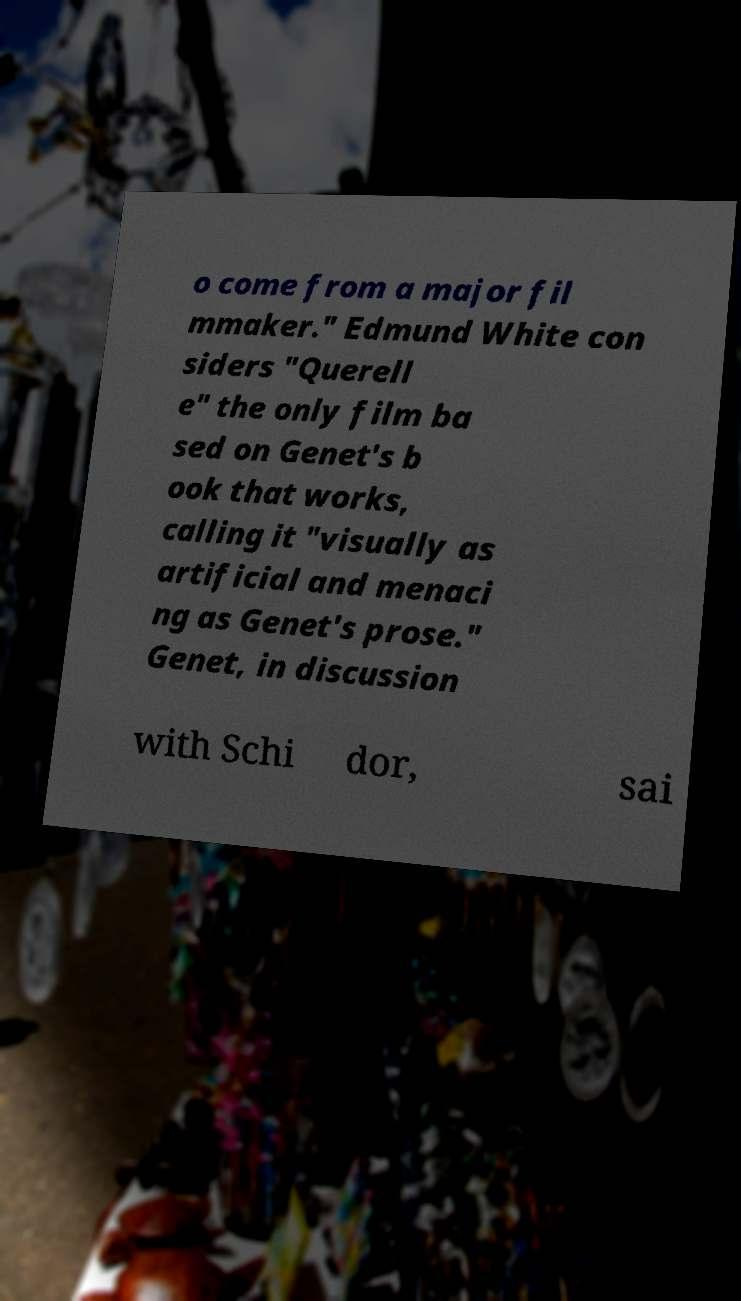What messages or text are displayed in this image? I need them in a readable, typed format. o come from a major fil mmaker." Edmund White con siders "Querell e" the only film ba sed on Genet's b ook that works, calling it "visually as artificial and menaci ng as Genet's prose." Genet, in discussion with Schi dor, sai 